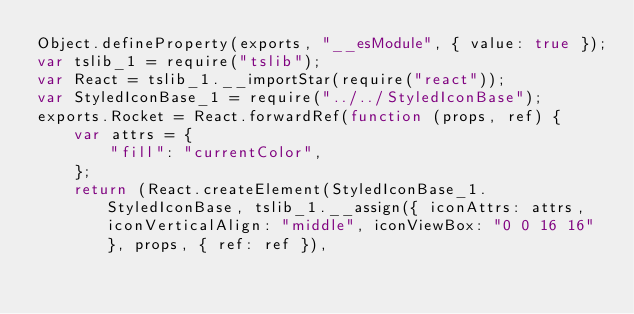<code> <loc_0><loc_0><loc_500><loc_500><_JavaScript_>Object.defineProperty(exports, "__esModule", { value: true });
var tslib_1 = require("tslib");
var React = tslib_1.__importStar(require("react"));
var StyledIconBase_1 = require("../../StyledIconBase");
exports.Rocket = React.forwardRef(function (props, ref) {
    var attrs = {
        "fill": "currentColor",
    };
    return (React.createElement(StyledIconBase_1.StyledIconBase, tslib_1.__assign({ iconAttrs: attrs, iconVerticalAlign: "middle", iconViewBox: "0 0 16 16" }, props, { ref: ref }),</code> 